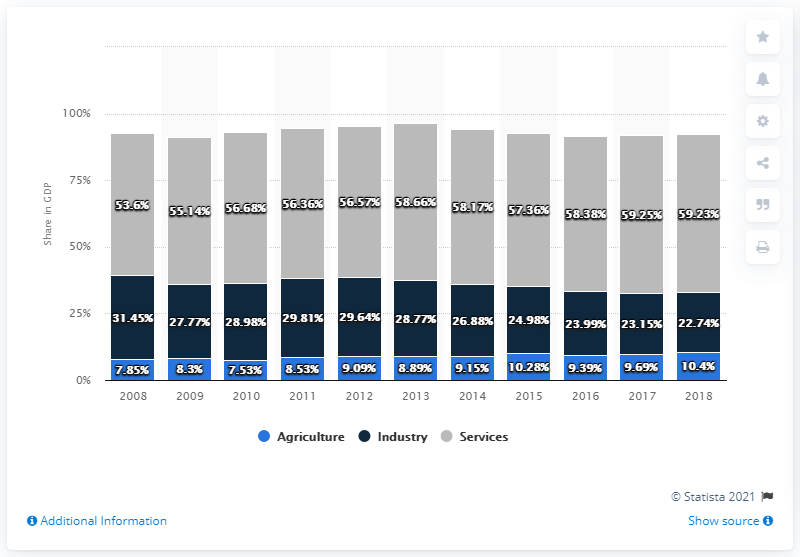Point out several critical features in this image. In 2018, the agriculture sector accounted for 10.4% of Tunisia's gross domestic product. 